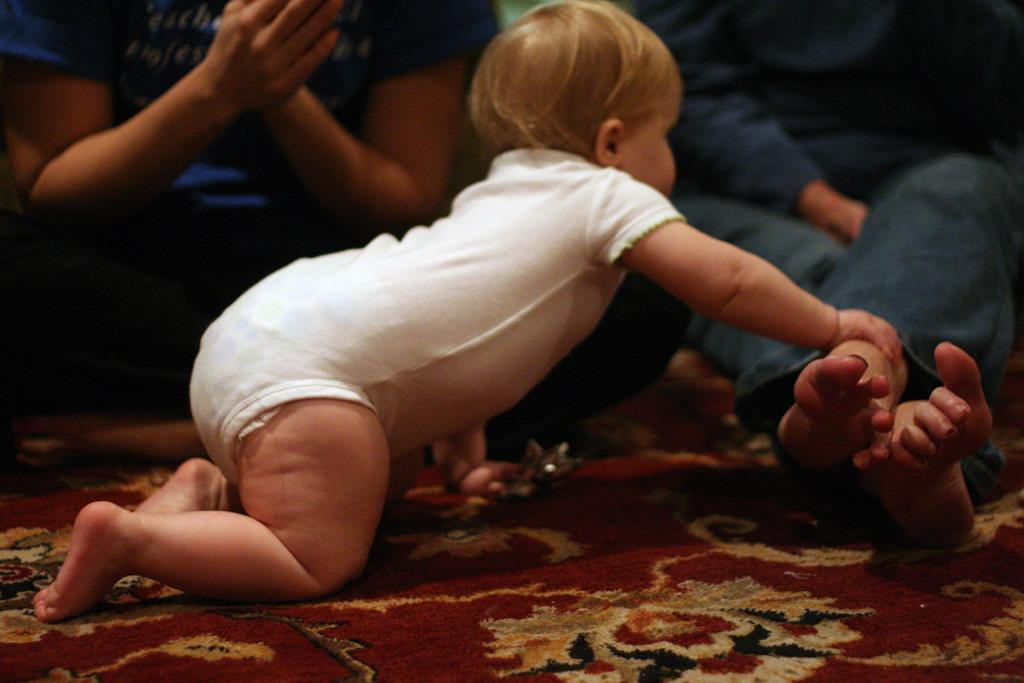What is the main subject of the picture? The main subject of the picture is a small baby. What is the baby wearing? The baby is wearing white clothes. What is the baby doing in the picture? The baby is crawling on a red carpet. Is the baby interacting with anyone or anything in the picture? Yes, the baby is holding a person's leg. What type of bells can be heard ringing in the background of the image? There are no bells or sounds mentioned in the image, so it cannot be determined if any bells are ringing. 